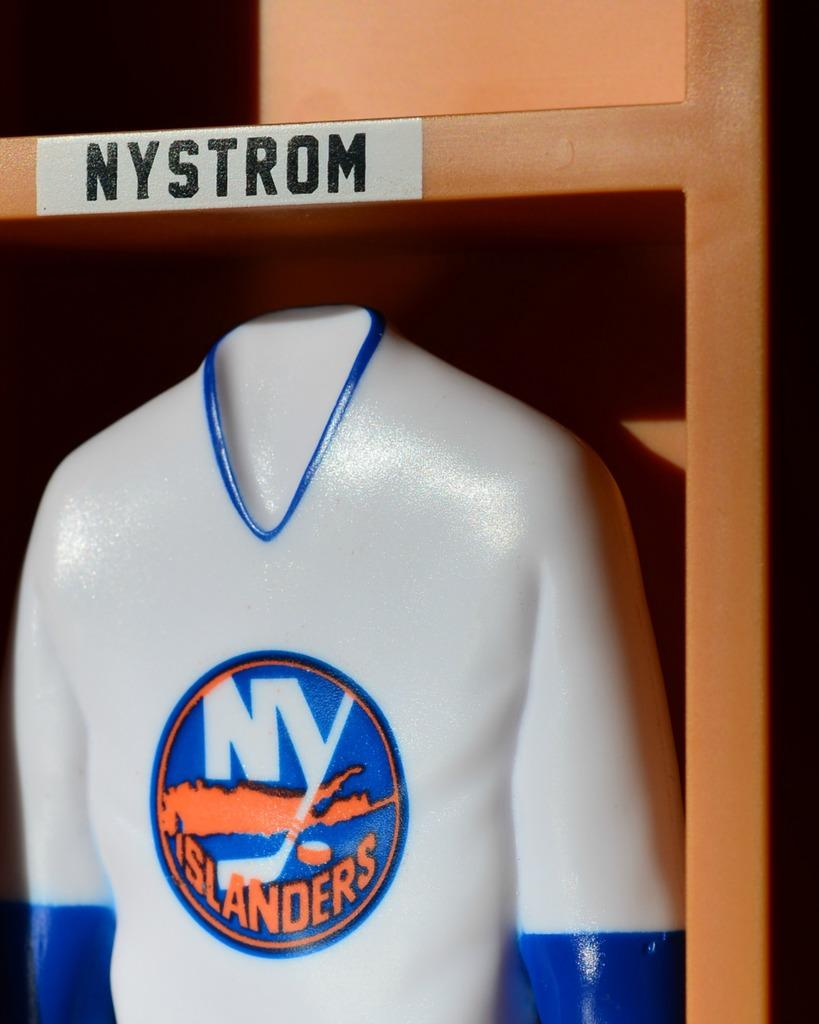Provide a one-sentence caption for the provided image. A mold of a human with a NY Islanders jersey on. 